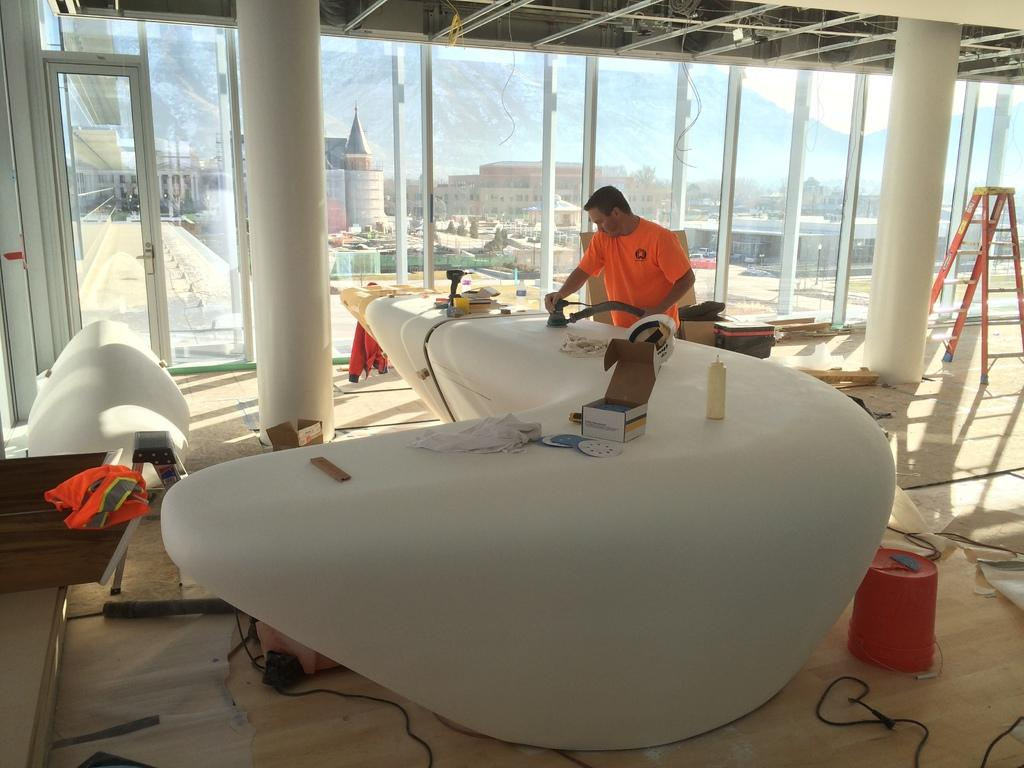What is the main subject of the image? There is a person in the image. What is the person wearing in the image? The person is wearing an orange shirt. What is the person doing in the image? The person is working. What can be seen in the background of the image? There are buildings in the background of the image. What type of income does the person earn from playing the guitar in the image? There is no guitar present in the image, and therefore no indication of the person earning income from playing it. Can you tell me how many insects are visible on the person's orange shirt in the image? There are no insects visible on the person's orange shirt in the image. 